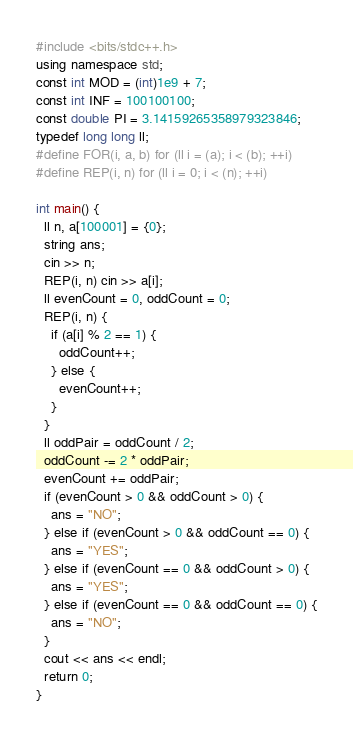Convert code to text. <code><loc_0><loc_0><loc_500><loc_500><_C++_>#include <bits/stdc++.h>
using namespace std;
const int MOD = (int)1e9 + 7;
const int INF = 100100100;
const double PI = 3.14159265358979323846;
typedef long long ll;
#define FOR(i, a, b) for (ll i = (a); i < (b); ++i)
#define REP(i, n) for (ll i = 0; i < (n); ++i)

int main() {
  ll n, a[100001] = {0};
  string ans;
  cin >> n;
  REP(i, n) cin >> a[i];
  ll evenCount = 0, oddCount = 0;
  REP(i, n) {
    if (a[i] % 2 == 1) {
      oddCount++;
    } else {
      evenCount++;
    }
  }
  ll oddPair = oddCount / 2;
  oddCount -= 2 * oddPair;
  evenCount += oddPair;
  if (evenCount > 0 && oddCount > 0) {
    ans = "NO";
  } else if (evenCount > 0 && oddCount == 0) {
    ans = "YES";
  } else if (evenCount == 0 && oddCount > 0) {
    ans = "YES";
  } else if (evenCount == 0 && oddCount == 0) {
    ans = "NO";
  }
  cout << ans << endl;
  return 0;
}</code> 